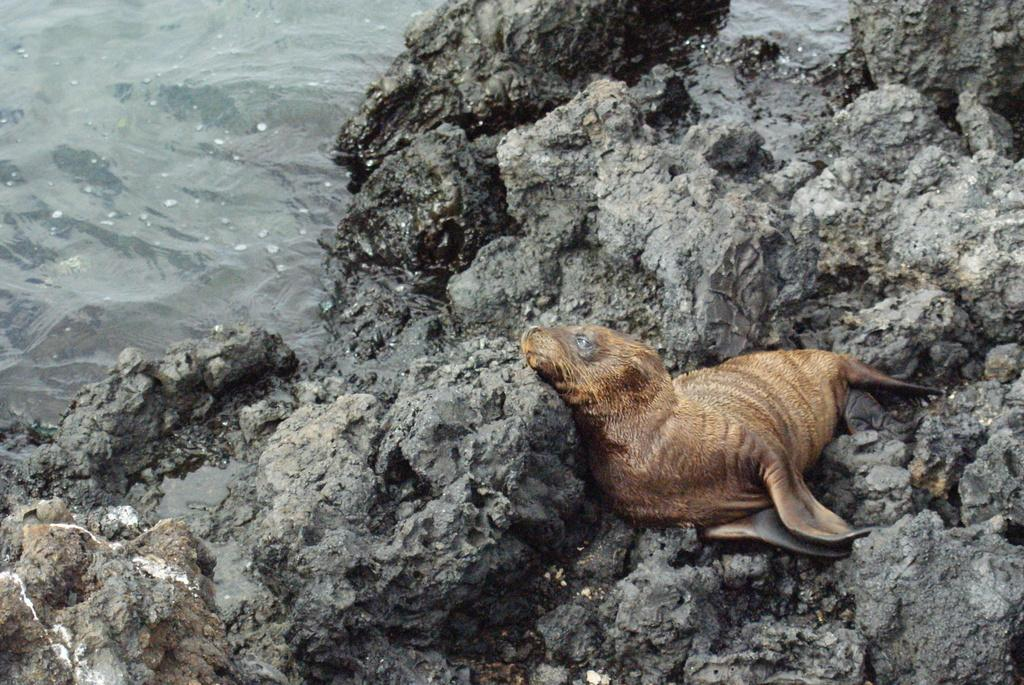What type of animal is in the image? The type of animal cannot be determined from the provided facts. Where is the animal located in the image? The animal is on the rocks in the image. What else can be seen in the image besides the animal? There is water visible in the image. What brand of soda is the animal holding in the image? There is no soda present in the image, and the animal is not holding anything. 